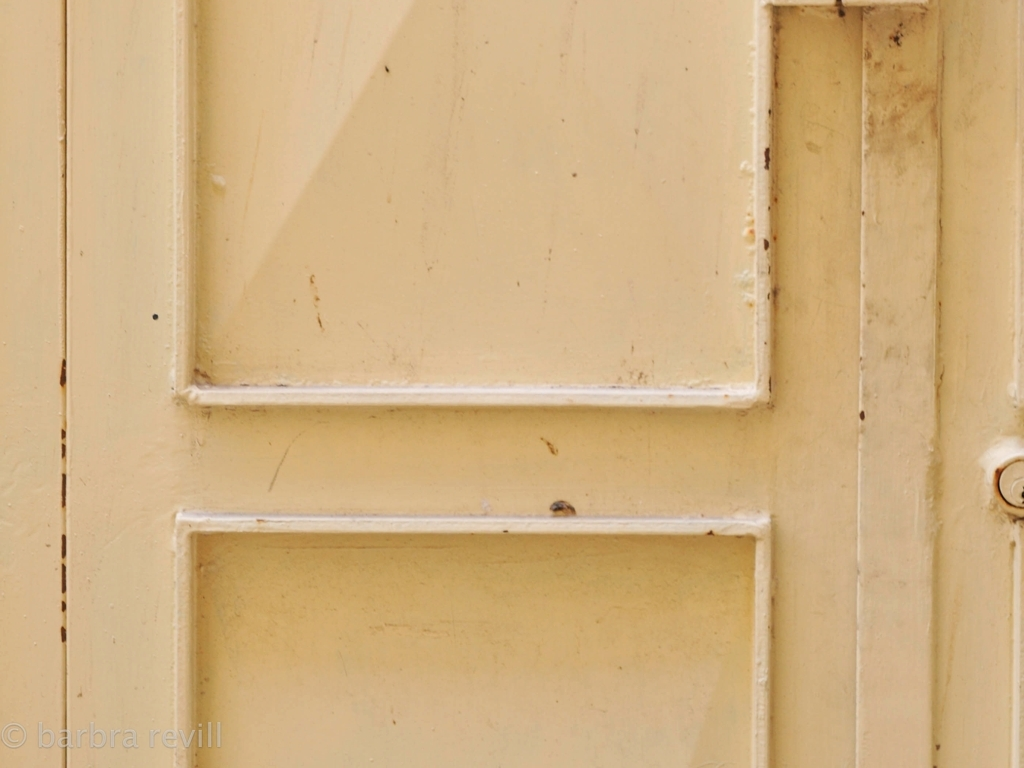How might you improve the photographically aesthetic quality of this image? To enhance the image's quality, one could adjust the lighting and contrast to add depth to the colors and emphasize the textures of the door. Capturing the image from a different angle might also provide a more dynamic composition, and post-processing could be used to sharpen the image and clean up minor imperfections. 